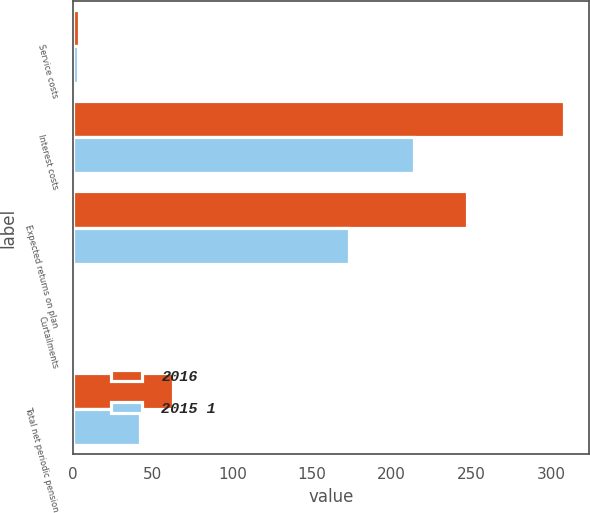Convert chart to OTSL. <chart><loc_0><loc_0><loc_500><loc_500><stacked_bar_chart><ecel><fcel>Service costs<fcel>Interest costs<fcel>Expected returns on plan<fcel>Curtailments<fcel>Total net periodic pension<nl><fcel>2016<fcel>4<fcel>308<fcel>247<fcel>2<fcel>63<nl><fcel>2015 1<fcel>3<fcel>214<fcel>173<fcel>2<fcel>42<nl></chart> 